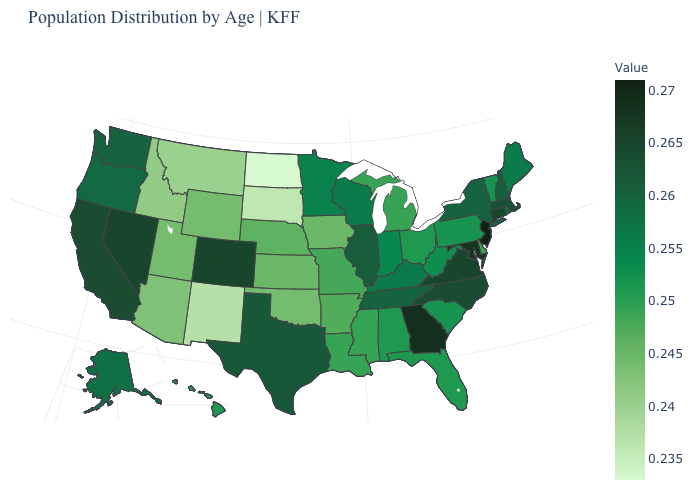Does the map have missing data?
Short answer required. No. Among the states that border Tennessee , does Arkansas have the lowest value?
Be succinct. Yes. Does the map have missing data?
Give a very brief answer. No. Among the states that border Indiana , which have the lowest value?
Write a very short answer. Michigan. Which states have the lowest value in the Northeast?
Write a very short answer. Pennsylvania, Vermont. 